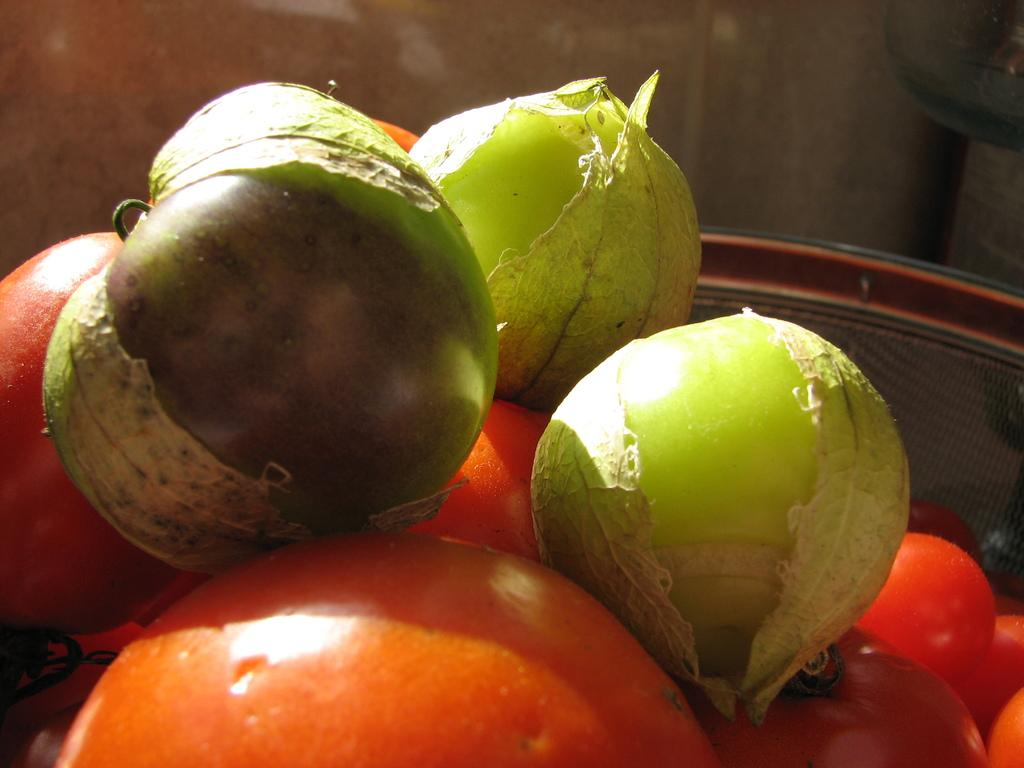What is in the bowl that is visible in the image? There are tomatoes in the bowl. Besides tomatoes, what else can be seen in the bowl? There are other unspecified things in the bowl. How does the skate move through the story in the image? There is no skate or story present in the image; it only features a bowl with tomatoes and other unspecified items. 